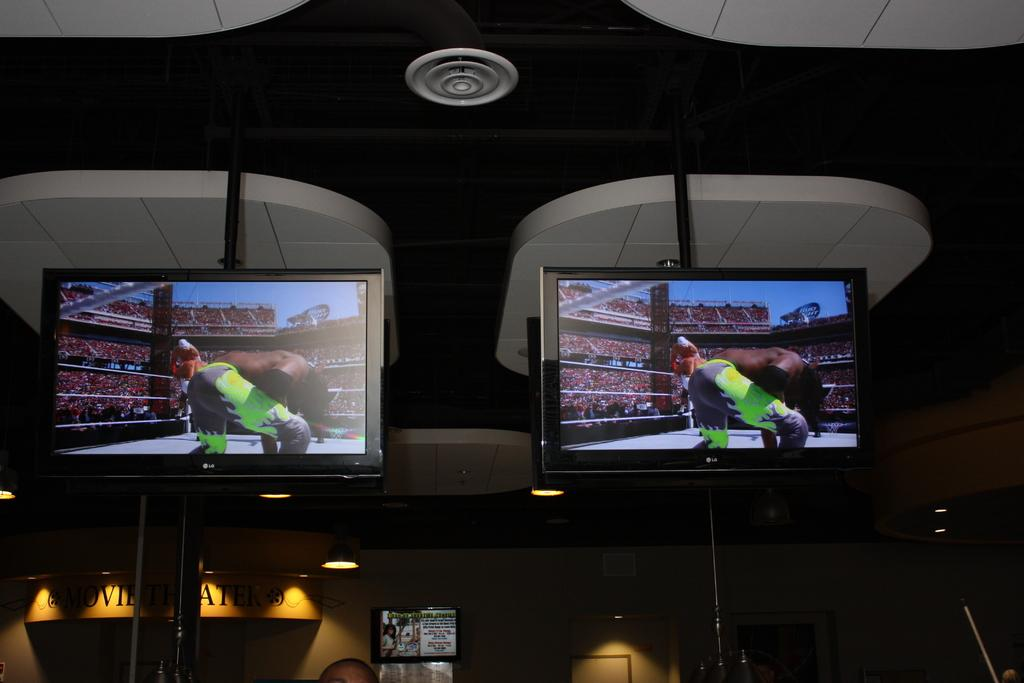<image>
Summarize the visual content of the image. Two LG branded televisions are hung from the ceiling are seen displaying pro wrestling on their screens. 